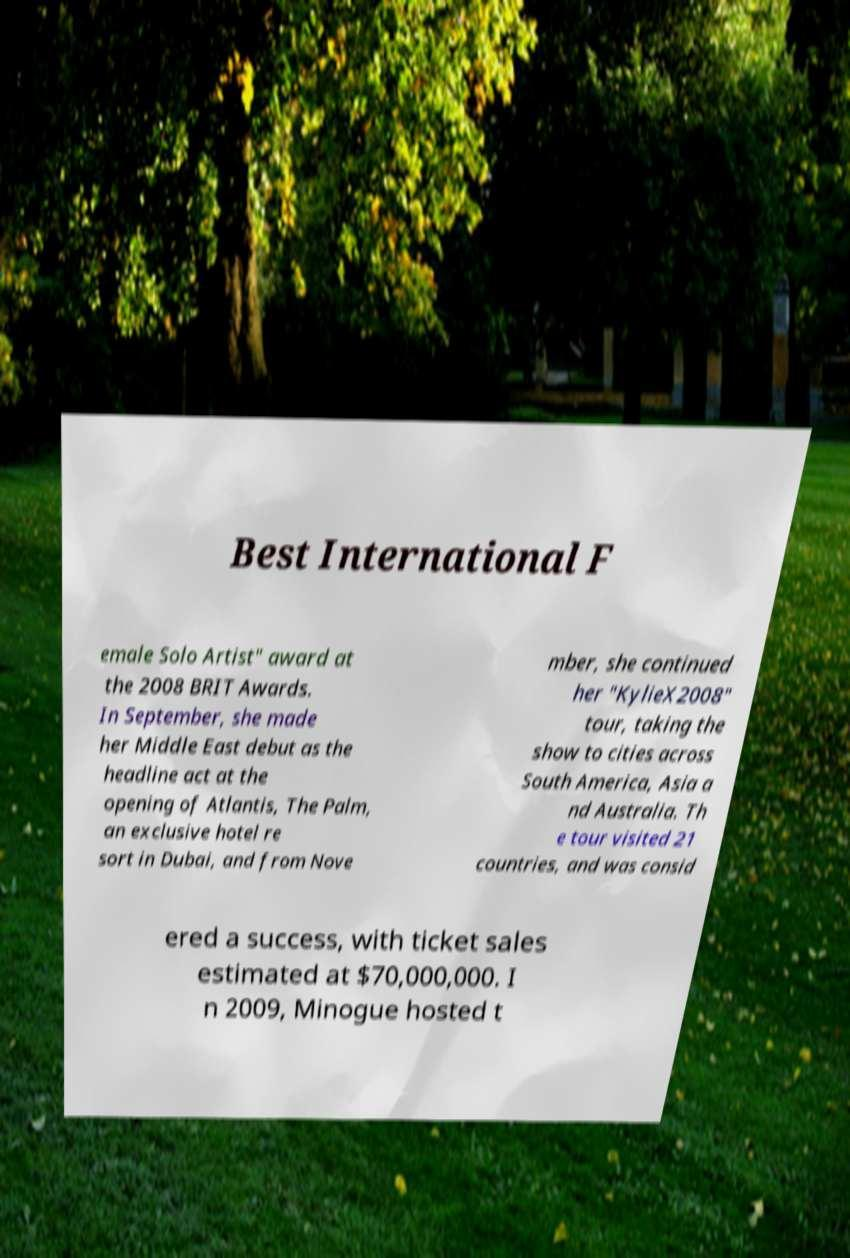Could you assist in decoding the text presented in this image and type it out clearly? Best International F emale Solo Artist" award at the 2008 BRIT Awards. In September, she made her Middle East debut as the headline act at the opening of Atlantis, The Palm, an exclusive hotel re sort in Dubai, and from Nove mber, she continued her "KylieX2008" tour, taking the show to cities across South America, Asia a nd Australia. Th e tour visited 21 countries, and was consid ered a success, with ticket sales estimated at $70,000,000. I n 2009, Minogue hosted t 